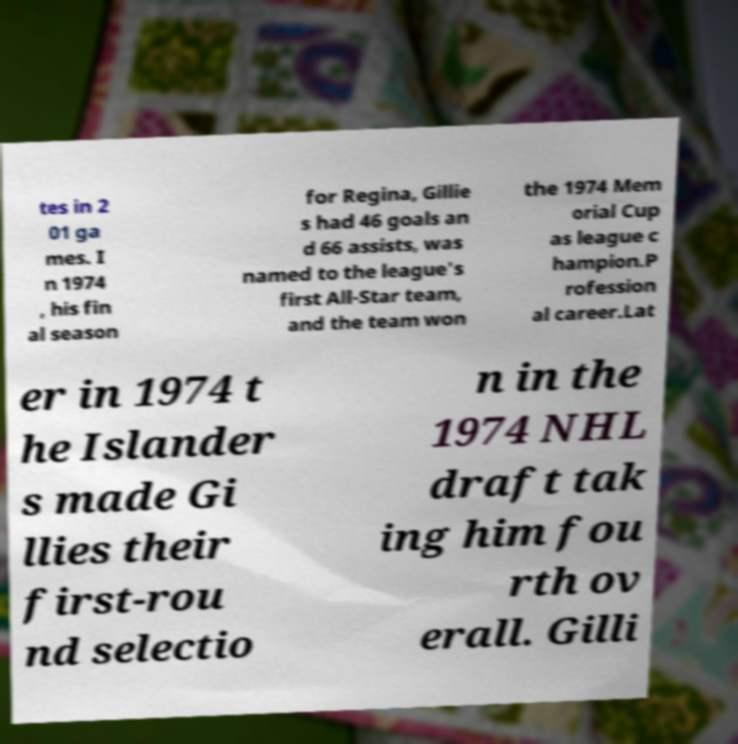Could you assist in decoding the text presented in this image and type it out clearly? tes in 2 01 ga mes. I n 1974 , his fin al season for Regina, Gillie s had 46 goals an d 66 assists, was named to the league's first All-Star team, and the team won the 1974 Mem orial Cup as league c hampion.P rofession al career.Lat er in 1974 t he Islander s made Gi llies their first-rou nd selectio n in the 1974 NHL draft tak ing him fou rth ov erall. Gilli 